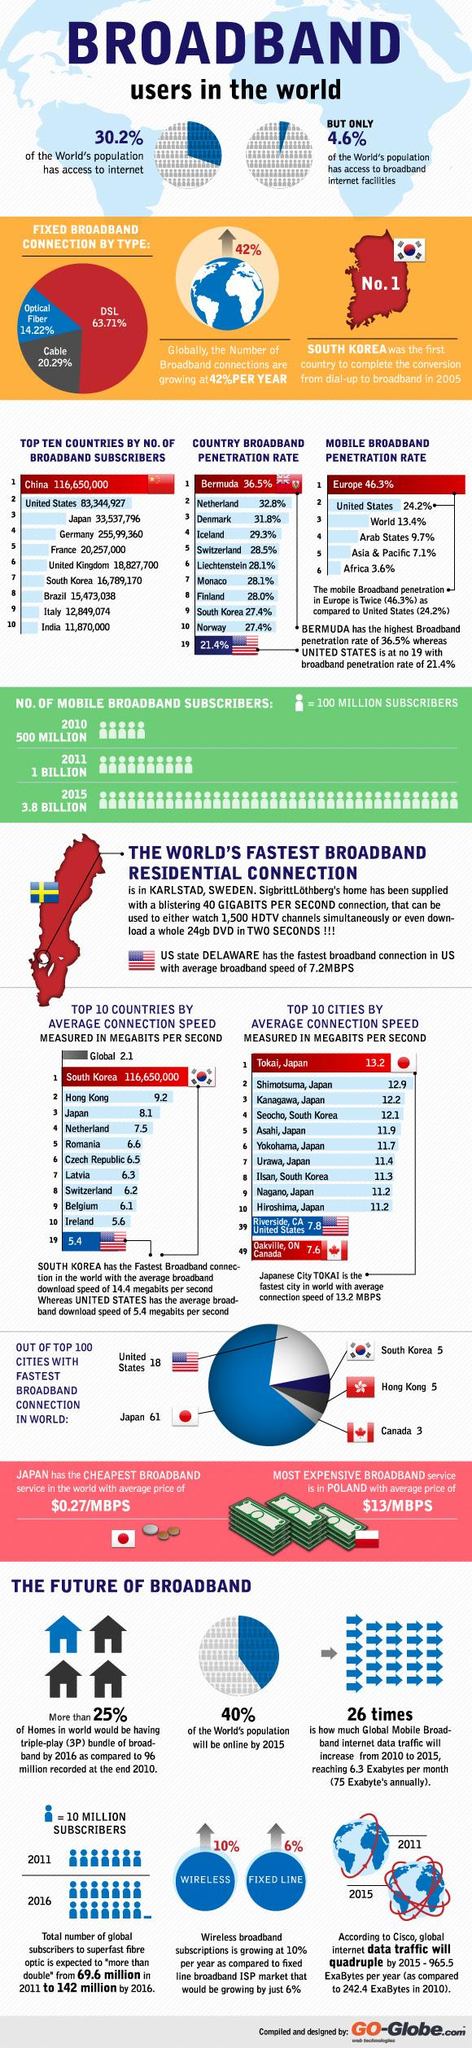Give some essential details in this illustration. In 2011, there were one billion mobile broadband subscribers. According to recent data, approximately 14.22% of broadband users worldwide use optical fiber connections for their internet access. According to recent studies, the majority of broadband users worldwide use DSL as their primary broadband connection. The lack of internet access for a significant portion of the world's population, estimated to be 69.8%, highlights the need for increased efforts to bridge the digital divide and ensure equitable access to information and communication technologies. According to data, the broadband penetration rate in South Korea is 27.4%. 